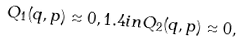<formula> <loc_0><loc_0><loc_500><loc_500>Q _ { 1 } ( q , p ) \approx 0 , 1 . 4 i n Q _ { 2 } ( q , p ) \approx 0 ,</formula> 